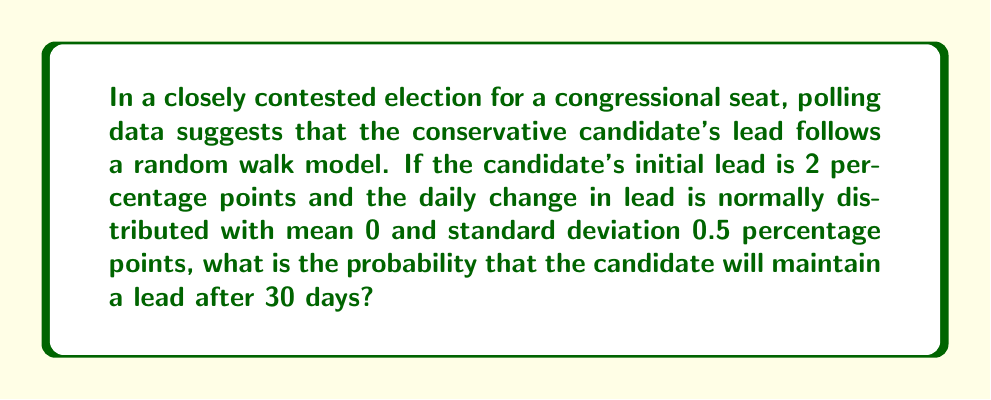What is the answer to this math problem? To solve this problem, we'll use the properties of random walk models and the normal distribution:

1) In a random walk model, the position after n steps is normally distributed with:
   Mean = Initial position
   Variance = n * (step variance)

2) In this case:
   Initial position = 2 percentage points
   n = 30 days
   Step variance = 0.5^2 = 0.25

3) After 30 days, the lead will be normally distributed with:
   Mean = 2
   Variance = 30 * 0.25 = 7.5
   Standard deviation = $\sqrt{7.5} \approx 2.74$

4) We want to find the probability that the lead is greater than 0 after 30 days.

5) We can standardize this using the z-score formula:
   $$z = \frac{x - \mu}{\sigma} = \frac{0 - 2}{2.74} \approx -0.73$$

6) The probability of maintaining a lead is the area to the right of z = -0.73 on a standard normal distribution.

7) Using a standard normal table or calculator, we find:
   P(Z > -0.73) ≈ 0.7673

Therefore, the probability of maintaining a lead after 30 days is approximately 0.7673 or 76.73%.
Answer: 0.7673 